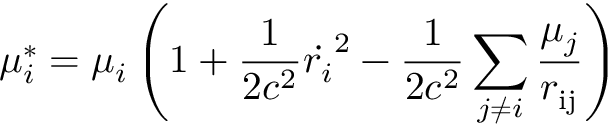Convert formula to latex. <formula><loc_0><loc_0><loc_500><loc_500>\mu _ { i } ^ { * } = \mu _ { i } \left ( 1 + \frac { 1 } { 2 c ^ { 2 } } \dot { r _ { i } } ^ { 2 } - \frac { 1 } { 2 c ^ { 2 } } \sum _ { j \neq i } \frac { \mu _ { j } } { r _ { i j } } \right )</formula> 